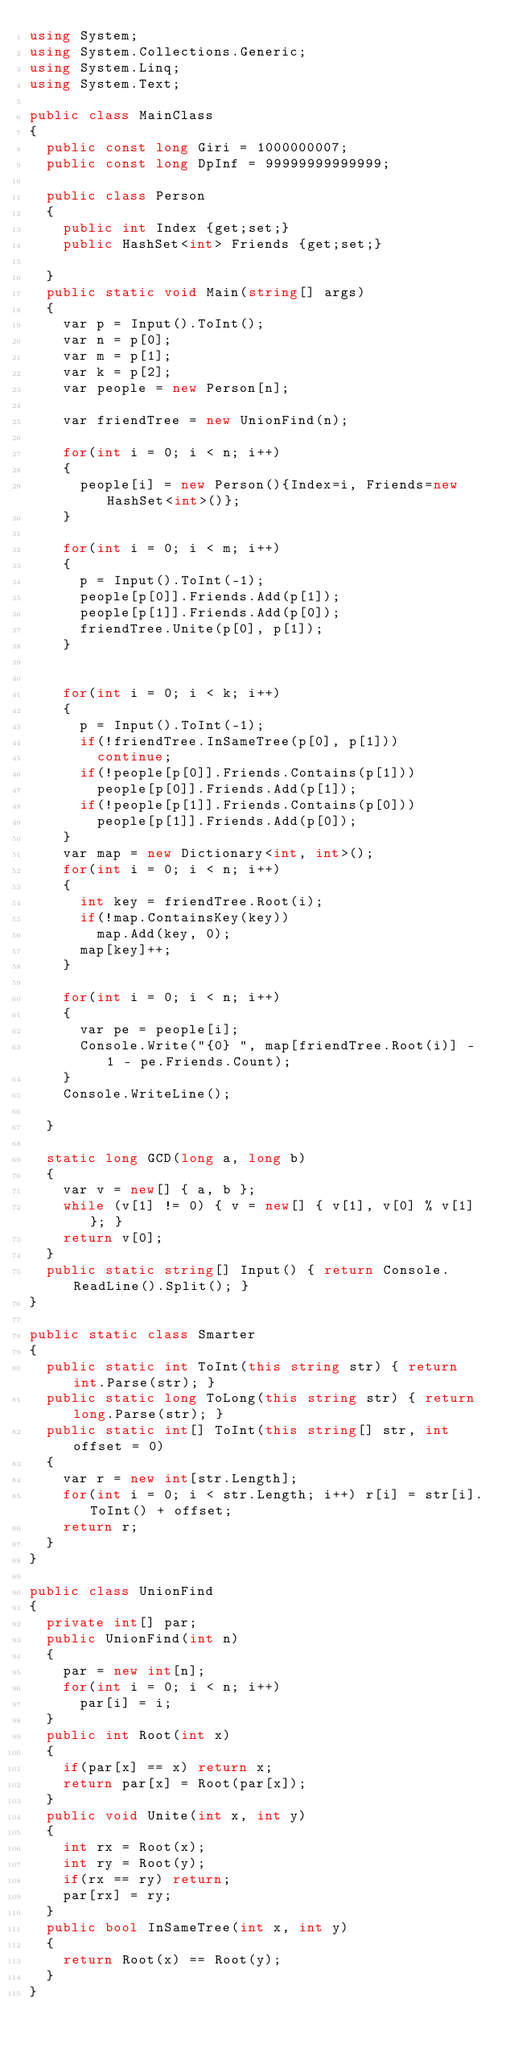<code> <loc_0><loc_0><loc_500><loc_500><_C#_>using System;
using System.Collections.Generic;
using System.Linq;
using System.Text;

public class MainClass
{
	public const long Giri = 1000000007;
	public const long DpInf = 99999999999999;
	
	public class Person
	{
		public int Index {get;set;}
		public HashSet<int> Friends {get;set;}
		
	}
	public static void Main(string[] args)
	{
		var p = Input().ToInt();
		var n = p[0];
		var m = p[1];
		var k = p[2];
		var people = new Person[n];
		
		var friendTree = new UnionFind(n);
		
		for(int i = 0; i < n; i++)
		{
			people[i] = new Person(){Index=i, Friends=new HashSet<int>()};
		}
		
		for(int i = 0; i < m; i++)
		{
			p = Input().ToInt(-1);
			people[p[0]].Friends.Add(p[1]);
			people[p[1]].Friends.Add(p[0]);
			friendTree.Unite(p[0], p[1]);
		}
		
		
		for(int i = 0; i < k; i++)
		{
			p = Input().ToInt(-1);
			if(!friendTree.InSameTree(p[0], p[1]))
				continue;
			if(!people[p[0]].Friends.Contains(p[1]))
				people[p[0]].Friends.Add(p[1]);
			if(!people[p[1]].Friends.Contains(p[0]))
				people[p[1]].Friends.Add(p[0]);
		}
		var map = new Dictionary<int, int>();
		for(int i = 0; i < n; i++)
		{
			int key = friendTree.Root(i);
			if(!map.ContainsKey(key))
				map.Add(key, 0);
			map[key]++;
		}
		
		for(int i = 0; i < n; i++)
		{
			var pe = people[i];
			Console.Write("{0} ", map[friendTree.Root(i)] - 1 - pe.Friends.Count);
		}
		Console.WriteLine();
		
	}
	
	static long GCD(long a, long b)
	{
		var v = new[] { a, b };
		while (v[1] != 0) { v = new[] { v[1], v[0] % v[1] }; }
		return v[0];
	}
	public static string[] Input() { return Console.ReadLine().Split(); }
}

public static class Smarter
{
	public static int ToInt(this string str) { return int.Parse(str); }
	public static long ToLong(this string str) { return long.Parse(str); }
	public static int[] ToInt(this string[] str, int offset = 0)
	{
		var r = new int[str.Length];
		for(int i = 0; i < str.Length; i++) r[i] = str[i].ToInt() + offset;
		return r;
	}
}

public class UnionFind
{
	private int[] par;
	public UnionFind(int n)
	{
		par = new int[n];
		for(int i = 0; i < n; i++)
			par[i] = i;
	}
	public int Root(int x)
	{
		if(par[x] == x) return x;
		return par[x] = Root(par[x]);
	}
	public void Unite(int x, int y)
	{
		int rx = Root(x);
		int ry = Root(y);
		if(rx == ry) return;
		par[rx] = ry;
	}
	public bool InSameTree(int x, int y)
	{
		return Root(x) == Root(y);
	}
}
</code> 